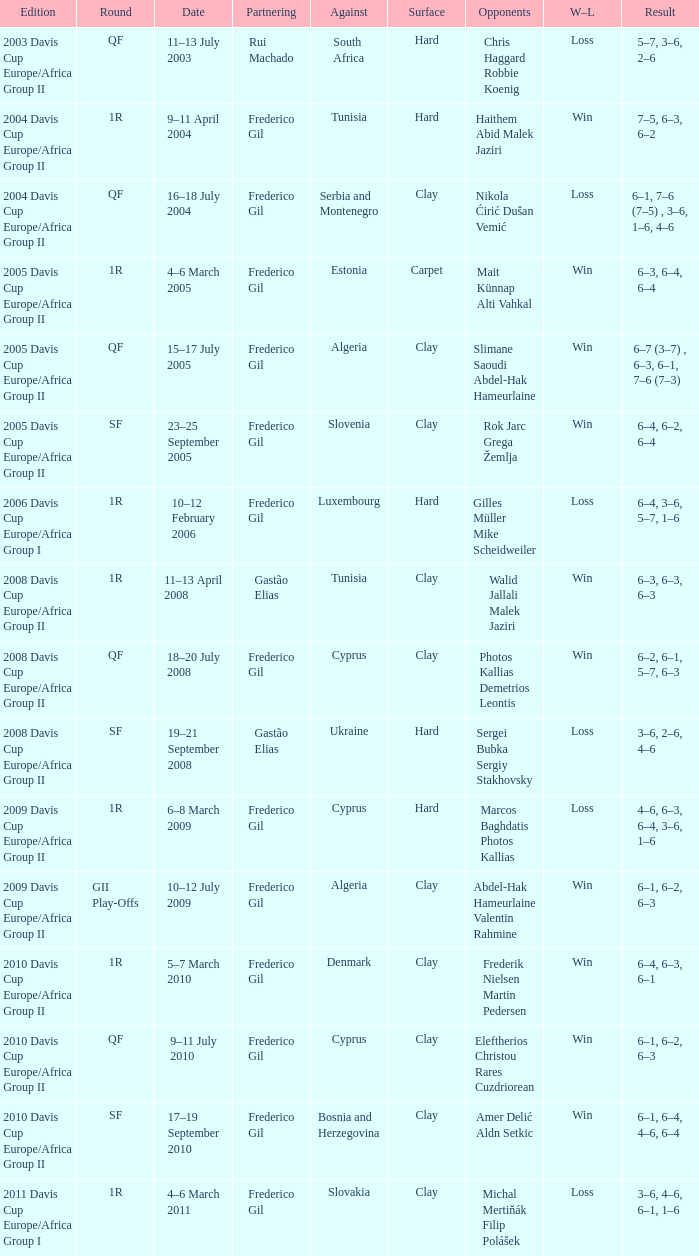How many rounds took place in the 2006 davis cup europe/africa group i? 1.0. 